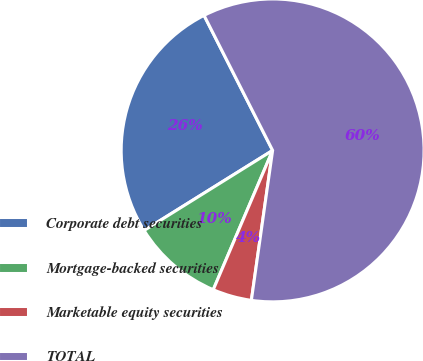Convert chart to OTSL. <chart><loc_0><loc_0><loc_500><loc_500><pie_chart><fcel>Corporate debt securities<fcel>Mortgage-backed securities<fcel>Marketable equity securities<fcel>TOTAL<nl><fcel>26.39%<fcel>9.72%<fcel>4.17%<fcel>59.72%<nl></chart> 